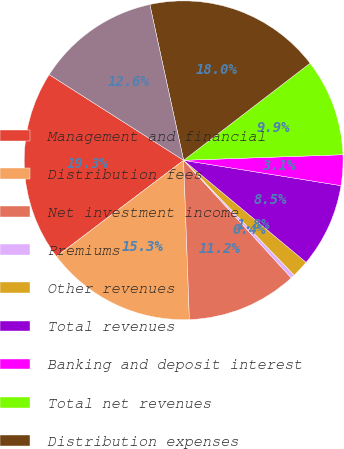Convert chart. <chart><loc_0><loc_0><loc_500><loc_500><pie_chart><fcel>Management and financial<fcel>Distribution fees<fcel>Net investment income<fcel>Premiums<fcel>Other revenues<fcel>Total revenues<fcel>Banking and deposit interest<fcel>Total net revenues<fcel>Distribution expenses<fcel>Interest credited to fixed<nl><fcel>19.33%<fcel>15.27%<fcel>11.22%<fcel>0.4%<fcel>1.75%<fcel>8.51%<fcel>3.1%<fcel>9.86%<fcel>17.98%<fcel>12.57%<nl></chart> 